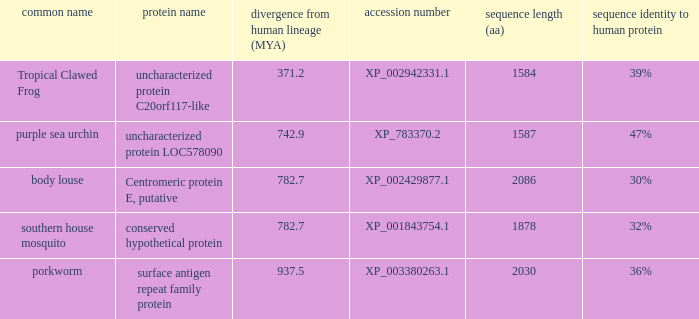What is the length of the protein sequence (in amino acids) for the purple sea urchin, considering a divergence from the human lineage of less than 742.9? None. Would you be able to parse every entry in this table? {'header': ['common name', 'protein name', 'divergence from human lineage (MYA)', 'accession number', 'sequence length (aa)', 'sequence identity to human protein'], 'rows': [['Tropical Clawed Frog', 'uncharacterized protein C20orf117-like', '371.2', 'XP_002942331.1', '1584', '39%'], ['purple sea urchin', 'uncharacterized protein LOC578090', '742.9', 'XP_783370.2', '1587', '47%'], ['body louse', 'Centromeric protein E, putative', '782.7', 'XP_002429877.1', '2086', '30%'], ['southern house mosquito', 'conserved hypothetical protein', '782.7', 'XP_001843754.1', '1878', '32%'], ['porkworm', 'surface antigen repeat family protein', '937.5', 'XP_003380263.1', '2030', '36%']]} 